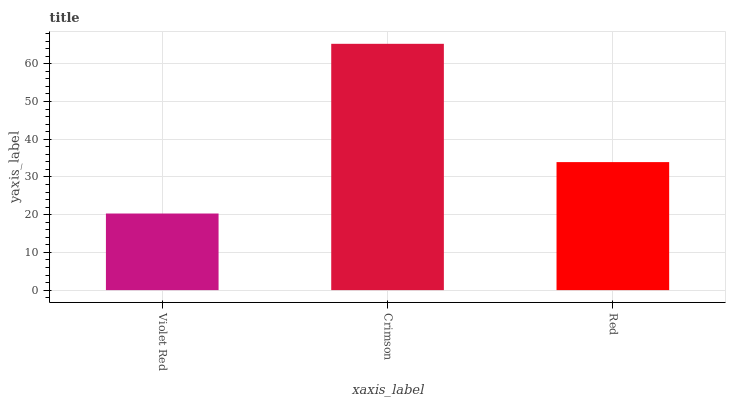Is Violet Red the minimum?
Answer yes or no. Yes. Is Crimson the maximum?
Answer yes or no. Yes. Is Red the minimum?
Answer yes or no. No. Is Red the maximum?
Answer yes or no. No. Is Crimson greater than Red?
Answer yes or no. Yes. Is Red less than Crimson?
Answer yes or no. Yes. Is Red greater than Crimson?
Answer yes or no. No. Is Crimson less than Red?
Answer yes or no. No. Is Red the high median?
Answer yes or no. Yes. Is Red the low median?
Answer yes or no. Yes. Is Crimson the high median?
Answer yes or no. No. Is Crimson the low median?
Answer yes or no. No. 